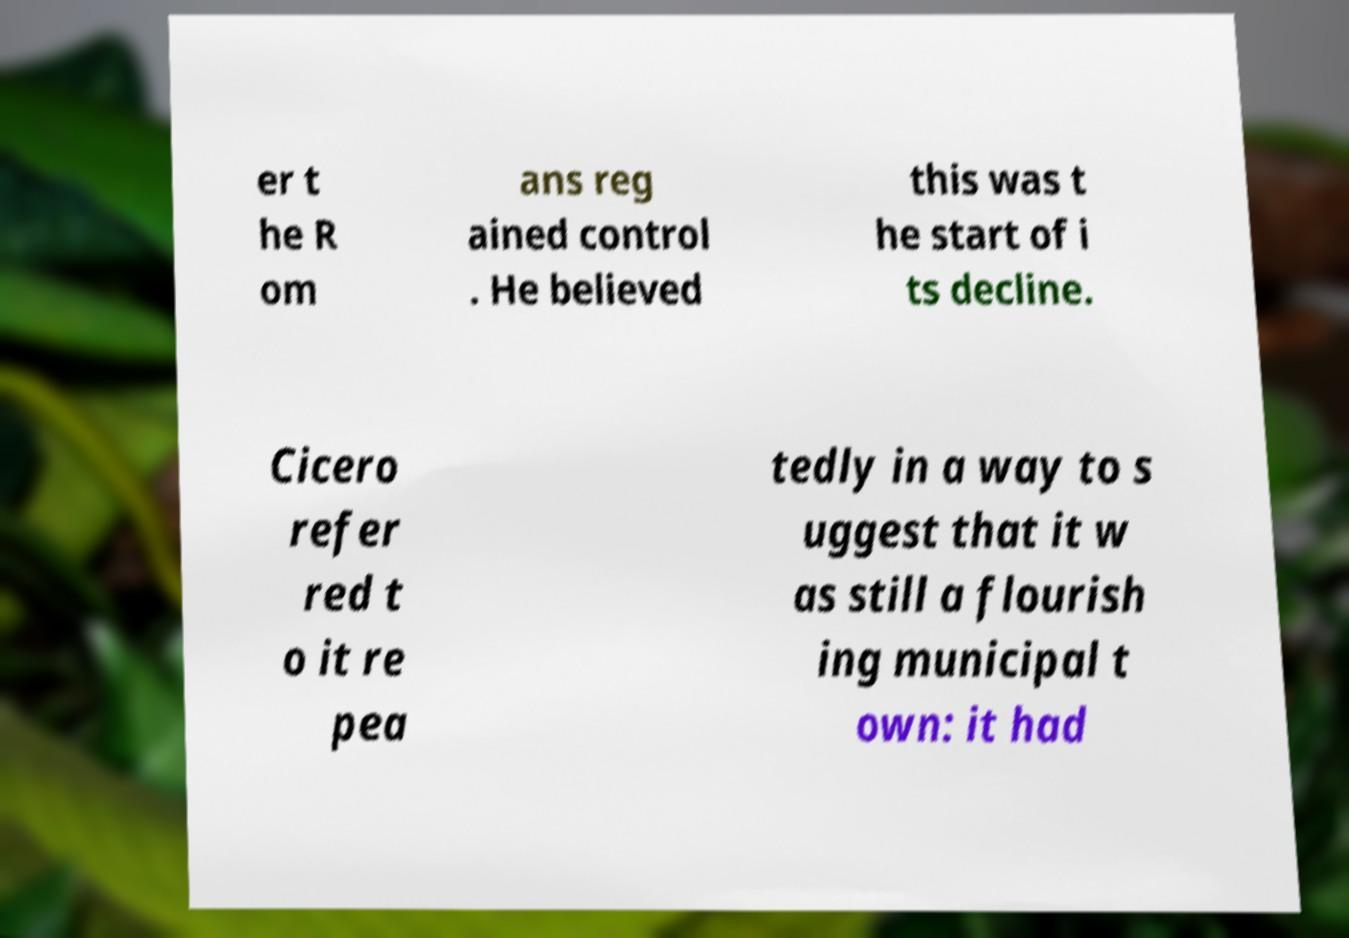Please read and relay the text visible in this image. What does it say? er t he R om ans reg ained control . He believed this was t he start of i ts decline. Cicero refer red t o it re pea tedly in a way to s uggest that it w as still a flourish ing municipal t own: it had 